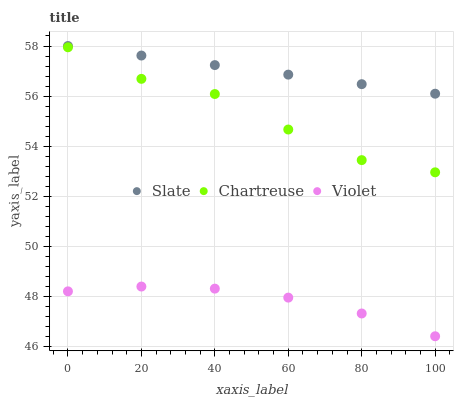Does Violet have the minimum area under the curve?
Answer yes or no. Yes. Does Slate have the maximum area under the curve?
Answer yes or no. Yes. Does Chartreuse have the minimum area under the curve?
Answer yes or no. No. Does Chartreuse have the maximum area under the curve?
Answer yes or no. No. Is Slate the smoothest?
Answer yes or no. Yes. Is Chartreuse the roughest?
Answer yes or no. Yes. Is Violet the smoothest?
Answer yes or no. No. Is Violet the roughest?
Answer yes or no. No. Does Violet have the lowest value?
Answer yes or no. Yes. Does Chartreuse have the lowest value?
Answer yes or no. No. Does Slate have the highest value?
Answer yes or no. Yes. Does Chartreuse have the highest value?
Answer yes or no. No. Is Violet less than Chartreuse?
Answer yes or no. Yes. Is Slate greater than Chartreuse?
Answer yes or no. Yes. Does Violet intersect Chartreuse?
Answer yes or no. No. 